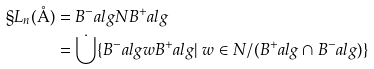Convert formula to latex. <formula><loc_0><loc_0><loc_500><loc_500>\S L _ { n } ( \AA ) & = B ^ { - } _ { \ } a l g N B ^ { + } _ { \ } a l g \\ & = \dot { \bigcup } \{ B ^ { - } _ { \ } a l g w B ^ { + } _ { \ } a l g | \ w \in N / ( B ^ { + } _ { \ } a l g \cap B ^ { - } _ { \ } a l g ) \}</formula> 